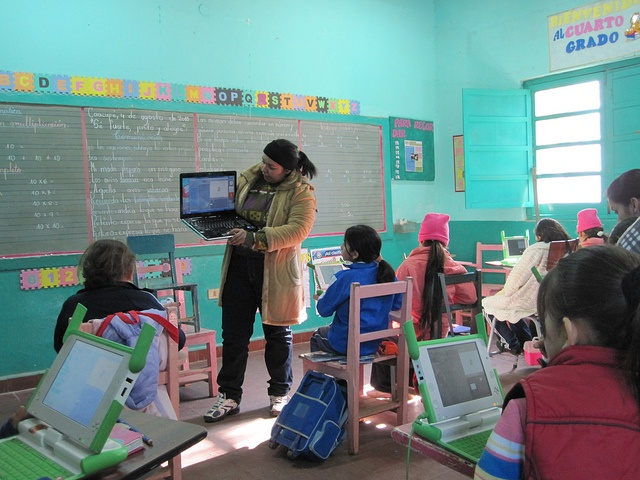Describe the objects in this image and their specific colors. I can see people in turquoise, brown, black, and gray tones, people in turquoise, black, gray, and darkgray tones, laptop in turquoise, gray, green, and darkgray tones, chair in turquoise, gray, and black tones, and laptop in turquoise, gray, darkgray, and green tones in this image. 